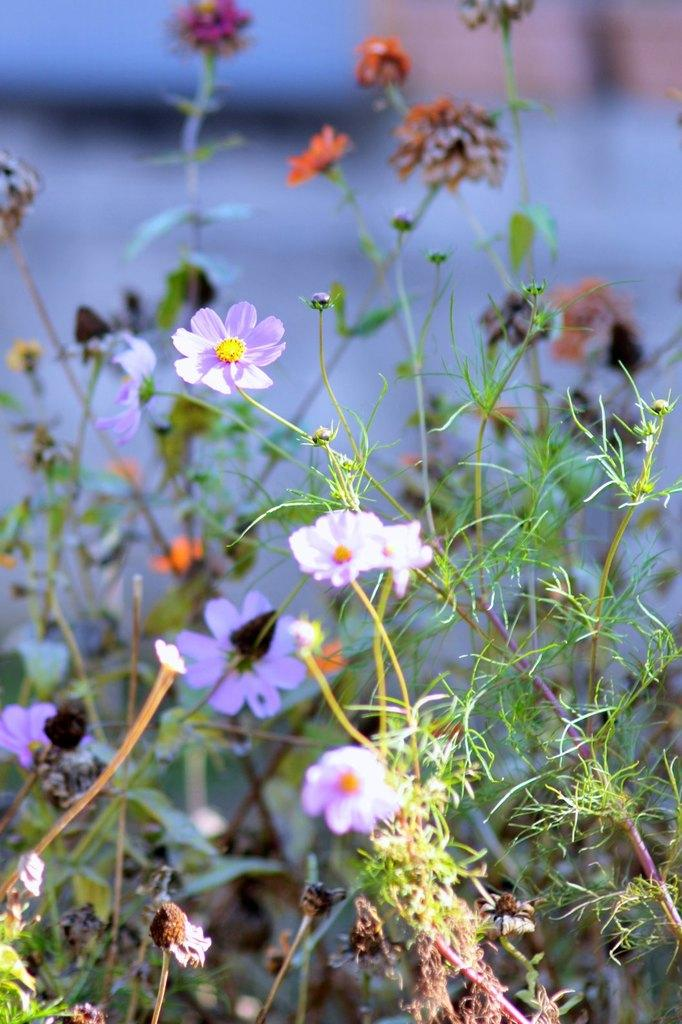What type of plants are visible in the image? There are flower plants in the image. Can you describe the background of the image? The background of the image is blurry. What type of cabbage can be seen growing near the seashore in the image? There is no cabbage or seashore present in the image; it features flower plants with a blurry background. 